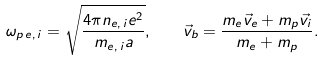Convert formula to latex. <formula><loc_0><loc_0><loc_500><loc_500>\omega _ { p \, e , \, i } = \sqrt { \frac { 4 \pi n _ { e , \, i } e ^ { 2 } } { m _ { e , \, i } a } } , \quad \vec { v } _ { b } = \frac { m _ { e } \vec { v } _ { e } + m _ { p } \vec { v } _ { i } } { m _ { e } + m _ { p } } .</formula> 